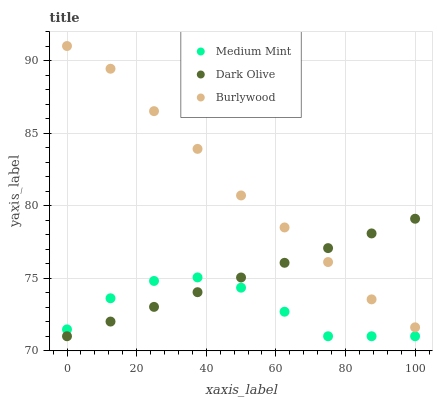Does Medium Mint have the minimum area under the curve?
Answer yes or no. Yes. Does Burlywood have the maximum area under the curve?
Answer yes or no. Yes. Does Dark Olive have the minimum area under the curve?
Answer yes or no. No. Does Dark Olive have the maximum area under the curve?
Answer yes or no. No. Is Dark Olive the smoothest?
Answer yes or no. Yes. Is Medium Mint the roughest?
Answer yes or no. Yes. Is Burlywood the smoothest?
Answer yes or no. No. Is Burlywood the roughest?
Answer yes or no. No. Does Medium Mint have the lowest value?
Answer yes or no. Yes. Does Burlywood have the lowest value?
Answer yes or no. No. Does Burlywood have the highest value?
Answer yes or no. Yes. Does Dark Olive have the highest value?
Answer yes or no. No. Is Medium Mint less than Burlywood?
Answer yes or no. Yes. Is Burlywood greater than Medium Mint?
Answer yes or no. Yes. Does Medium Mint intersect Dark Olive?
Answer yes or no. Yes. Is Medium Mint less than Dark Olive?
Answer yes or no. No. Is Medium Mint greater than Dark Olive?
Answer yes or no. No. Does Medium Mint intersect Burlywood?
Answer yes or no. No. 